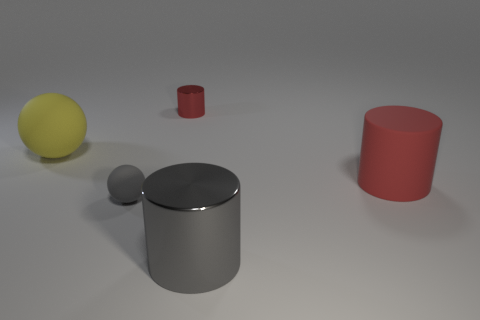What number of other objects are there of the same color as the big metal cylinder?
Offer a very short reply. 1. Do the object in front of the tiny gray rubber thing and the small thing that is in front of the red metallic object have the same material?
Offer a very short reply. No. How many things are either rubber objects right of the large yellow object or small gray matte cylinders?
Ensure brevity in your answer.  2. What number of things are either big gray things or matte things that are to the left of the big matte cylinder?
Your response must be concise. 3. What number of red rubber things have the same size as the red metal object?
Provide a succinct answer. 0. Are there fewer gray spheres that are behind the red metal thing than tiny cylinders that are in front of the big gray metal cylinder?
Your answer should be very brief. No. What number of shiny things are either small green cylinders or tiny gray balls?
Give a very brief answer. 0. What shape is the big gray metallic object?
Make the answer very short. Cylinder. What material is the red thing that is the same size as the gray rubber object?
Provide a succinct answer. Metal. What number of big objects are red objects or gray spheres?
Provide a succinct answer. 1. 